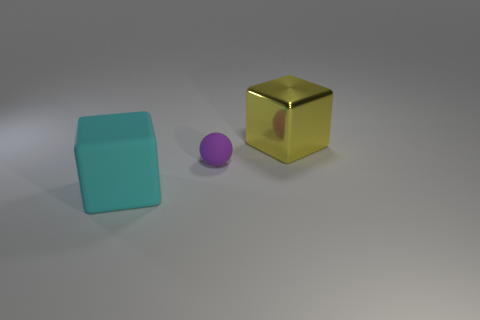Are there any other things that are the same size as the purple rubber object?
Provide a succinct answer. No. Are there more metallic blocks that are on the right side of the small purple matte ball than tiny green objects?
Provide a short and direct response. Yes. Is the shape of the large thing on the left side of the shiny block the same as  the large yellow object?
Make the answer very short. Yes. What number of cyan objects are either shiny blocks or rubber balls?
Offer a very short reply. 0. Is the number of cyan rubber cubes greater than the number of large green rubber objects?
Ensure brevity in your answer.  Yes. What color is the other object that is the same size as the yellow thing?
Offer a terse response. Cyan. How many cylinders are gray rubber objects or small purple matte objects?
Offer a terse response. 0. Is the shape of the large metallic thing the same as the thing in front of the ball?
Your response must be concise. Yes. What number of yellow shiny objects have the same size as the cyan block?
Provide a short and direct response. 1. There is a rubber thing behind the cyan matte thing; does it have the same shape as the large object that is to the left of the large yellow metal cube?
Give a very brief answer. No. 